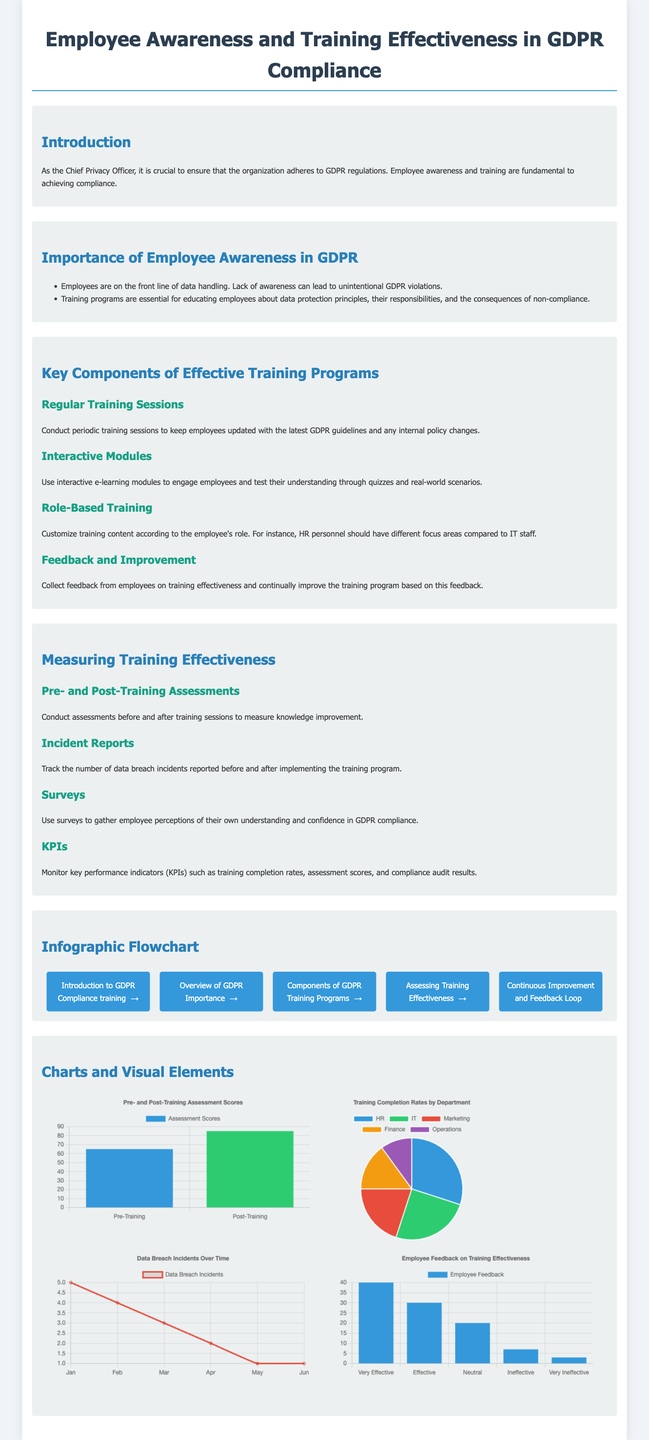What is the title of the infographic? The title of the infographic is presented in a prominent header at the top of the document, which states the main topic.
Answer: Employee Awareness and Training Effectiveness in GDPR Compliance How many key components of effective training programs are listed? The document mentions several components, and counting those listed provides the answer.
Answer: Four What was the assessment score before training? This score is retrieved from the pre- and post-training assessment section displayed in the chart.
Answer: 65 What is the main theme of the flowchart? The flowchart illustrates the steps taken in the training process related to GDPR compliance based on the text preceding it.
Answer: Training process steps Which department had the highest training completion rate? The pie chart specifies department completion rates, where the largest segment indicates the department with the highest rate.
Answer: HR What is the trend in data breach incidents from January to June? The line chart shows changes over time, allowing for the observation of the trend direction.
Answer: Decrease What percentage of employees rated the training as "Very Effective"? This percentage can be deduced from the survey results represented in a bar chart, which shows the distribution of feedback.
Answer: 40 What type of chart shows the training completion rates? The visual type representing the completion rates distinguishes itself based on the graphical representation format.
Answer: Pie chart What was the highest frequency of data breach incidents recorded in a month? The line chart indicates values for each month, which is analyzed to find the most frequent occurrences.
Answer: 5 